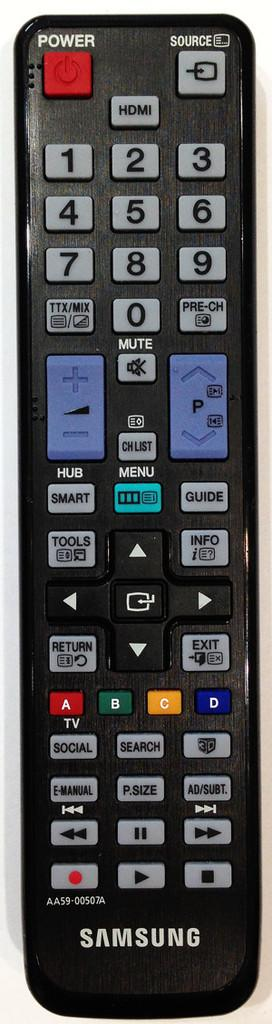<image>
Create a compact narrative representing the image presented. A Samsung remote control has a bright red Power button. 